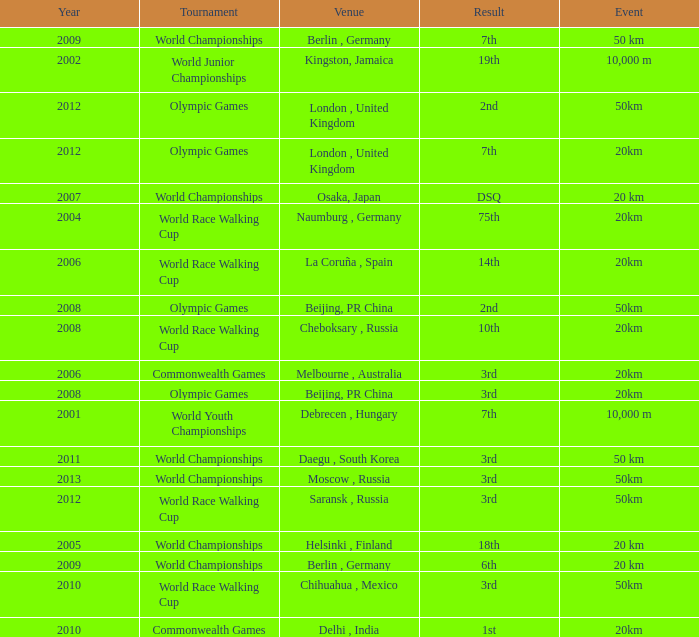What is the result of the World Race Walking Cup tournament played before the year 2010? 3rd. 